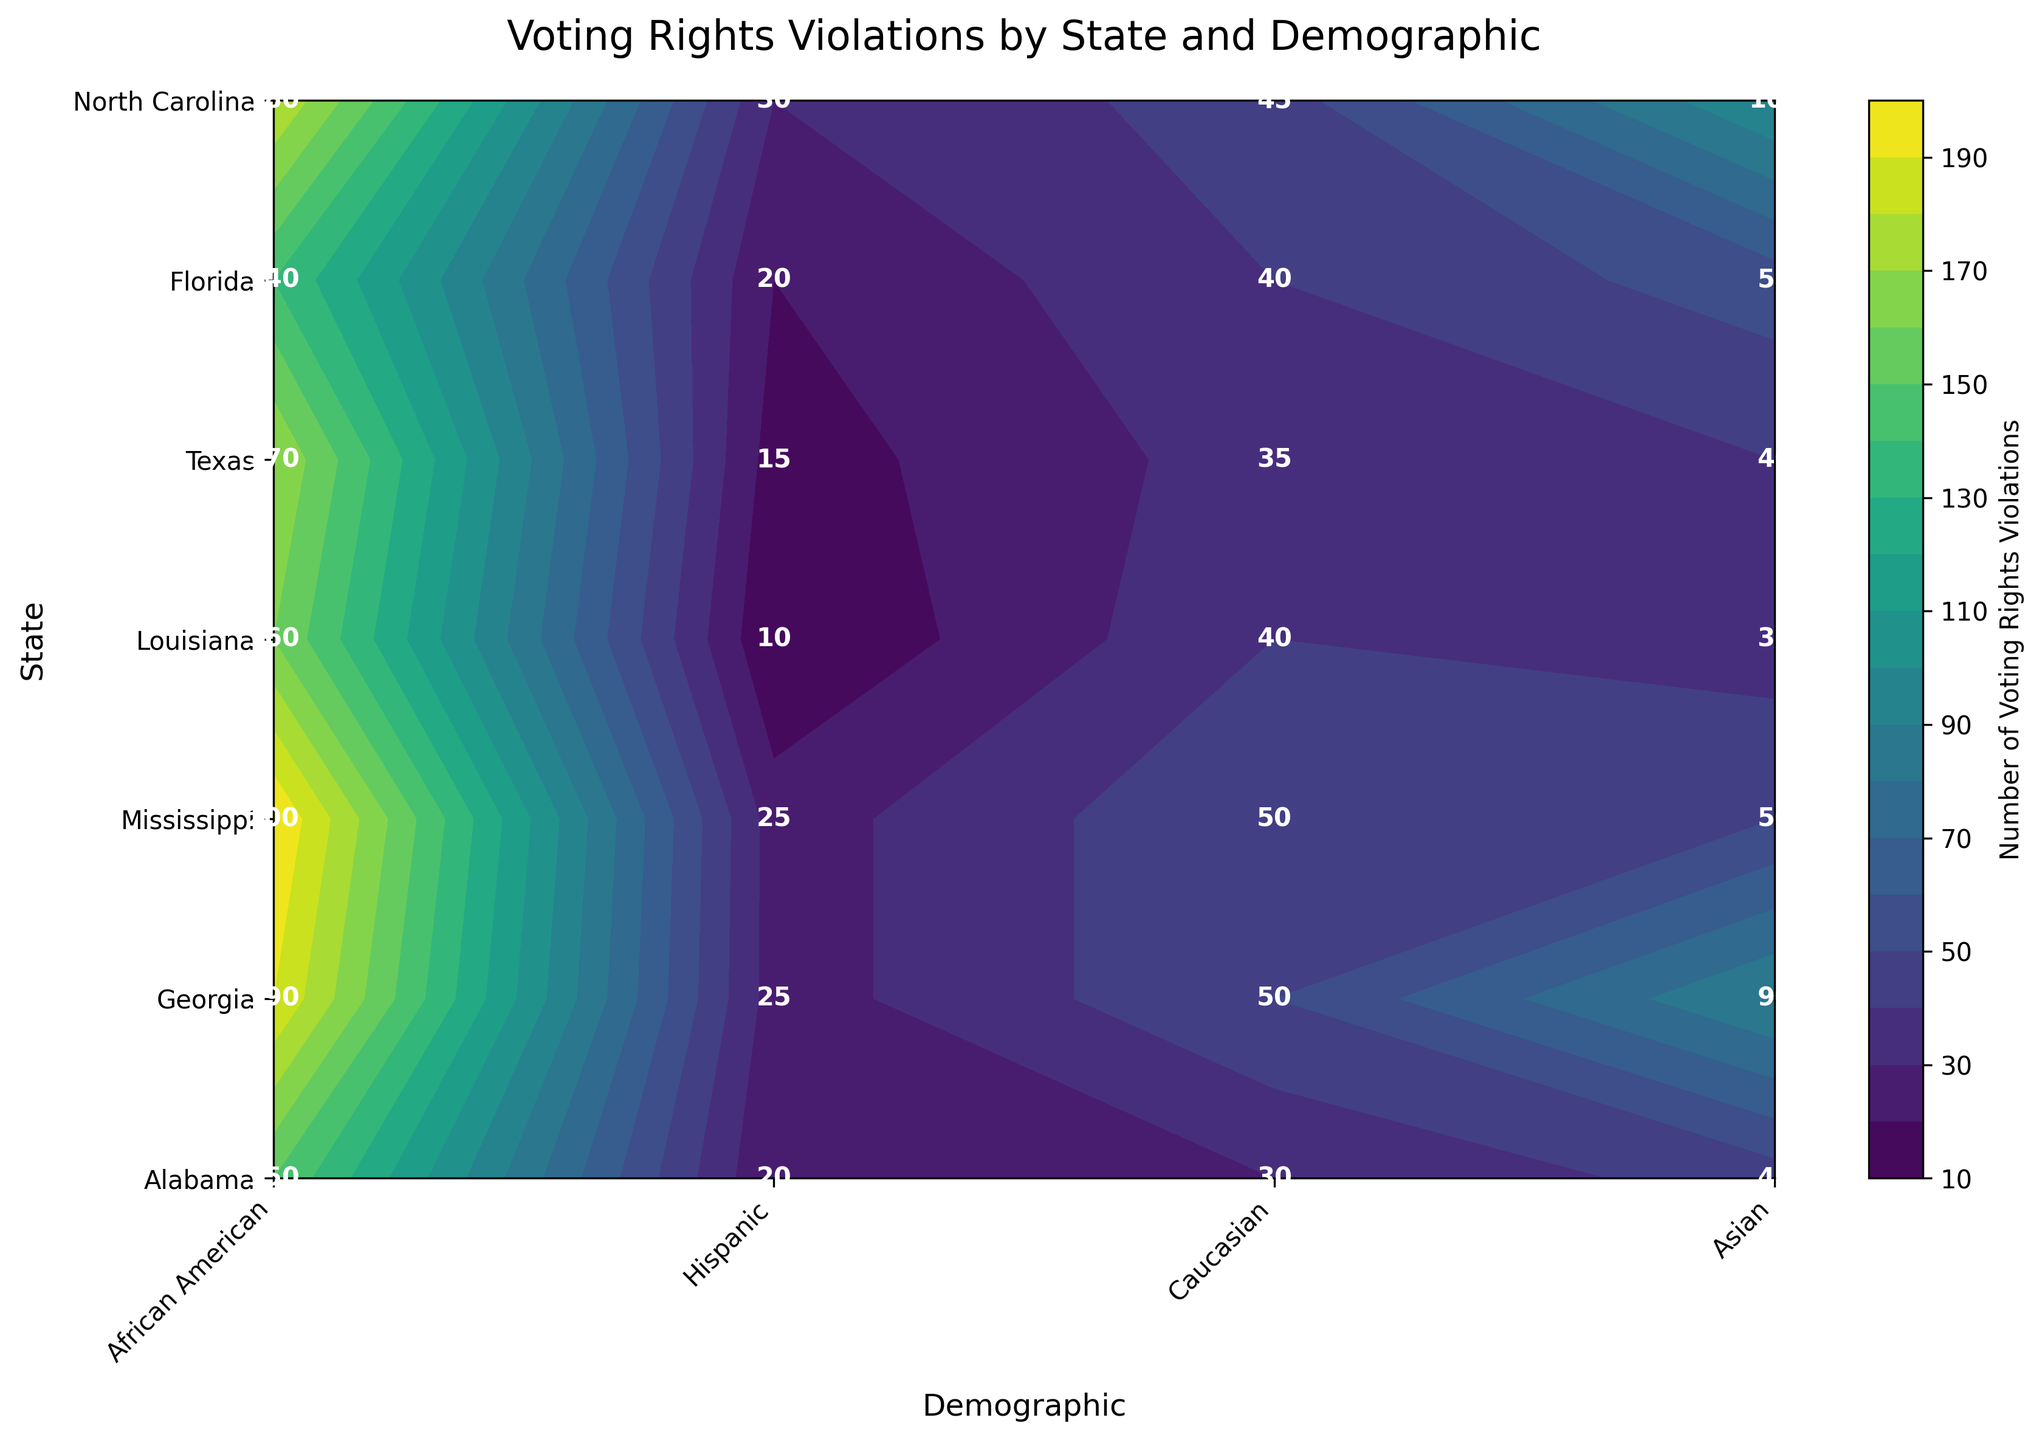What is the title of the plot? The title is located at the top of the figure, centered and in larger font, which typically describes the subject of the plot.
Answer: Voting Rights Violations by State and Demographic What is the color representing the highest number of voting rights violations? The contour plot uses a color gradient to represent different values, with the legend or color bar indicating which colors correspond to higher or lower values.
Answer: Darker shades (usually towards the end of the color gradient) Which state reports the highest number of voting rights violations for African Americans? Look at the labeled values on the Y-axis for states, then cross-reference the African American demographic on the X-axis to find the highest labeled number.
Answer: Georgia (200) Which demographic group in Texas has the least number of voting rights violations reported? Locate Texas on the Y-axis, and then find the smallest labeled number in that row corresponding to each demographic on the X-axis.
Answer: Asian (30) How many states have reported more than 150 voting rights violations for African Americans? Go through the African American column and count the number of states with values over 150.
Answer: 5 Compare the number of voting rights violations reported for Hispanics in Alabama and Texas. Which state has more violations? Locate the Hispanic demographic under both Alabama and Texas rows and compare their values.
Answer: Texas (100 vs. 45) Which demographic group shows the most equal distribution of voting rights violations among all states? Visually compare the spread and deviation of each demographic in the contour plot to see which has the most uniform color or similar values.
Answer: Caucasian What is the total number of voting rights violations reported in Florida across all demographics? Sum up the violations for each demographic in Florida (African American, Hispanic, Caucasian, Asian).
Answer: 190 + 90 + 50 + 25 = 355 Find the average number of voting rights violations reported for Asians across all states. Sum up the violations reported for Asians in all states and divide by the number of states.
Answer: (20+25+15+10+30+25+20) / 7 = 145 / 7 ≈ 20.7 Between African Americans in Mississippi and Hispanics in Florida, who experienced more reported voting rights violations and by how much? Compare the values for African Americans in Mississippi and Hispanics in Florida and calculate the difference.
Answer: African Americans in Mississippi; 170 - 90 = 80 more 